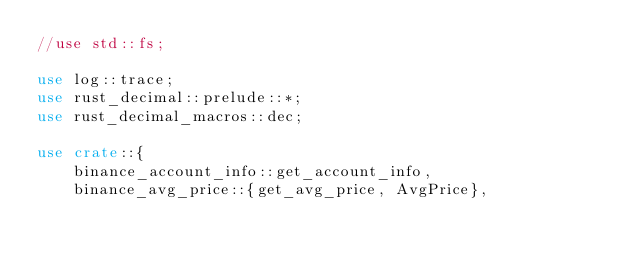<code> <loc_0><loc_0><loc_500><loc_500><_Rust_>//use std::fs;

use log::trace;
use rust_decimal::prelude::*;
use rust_decimal_macros::dec;

use crate::{
    binance_account_info::get_account_info,
    binance_avg_price::{get_avg_price, AvgPrice},</code> 